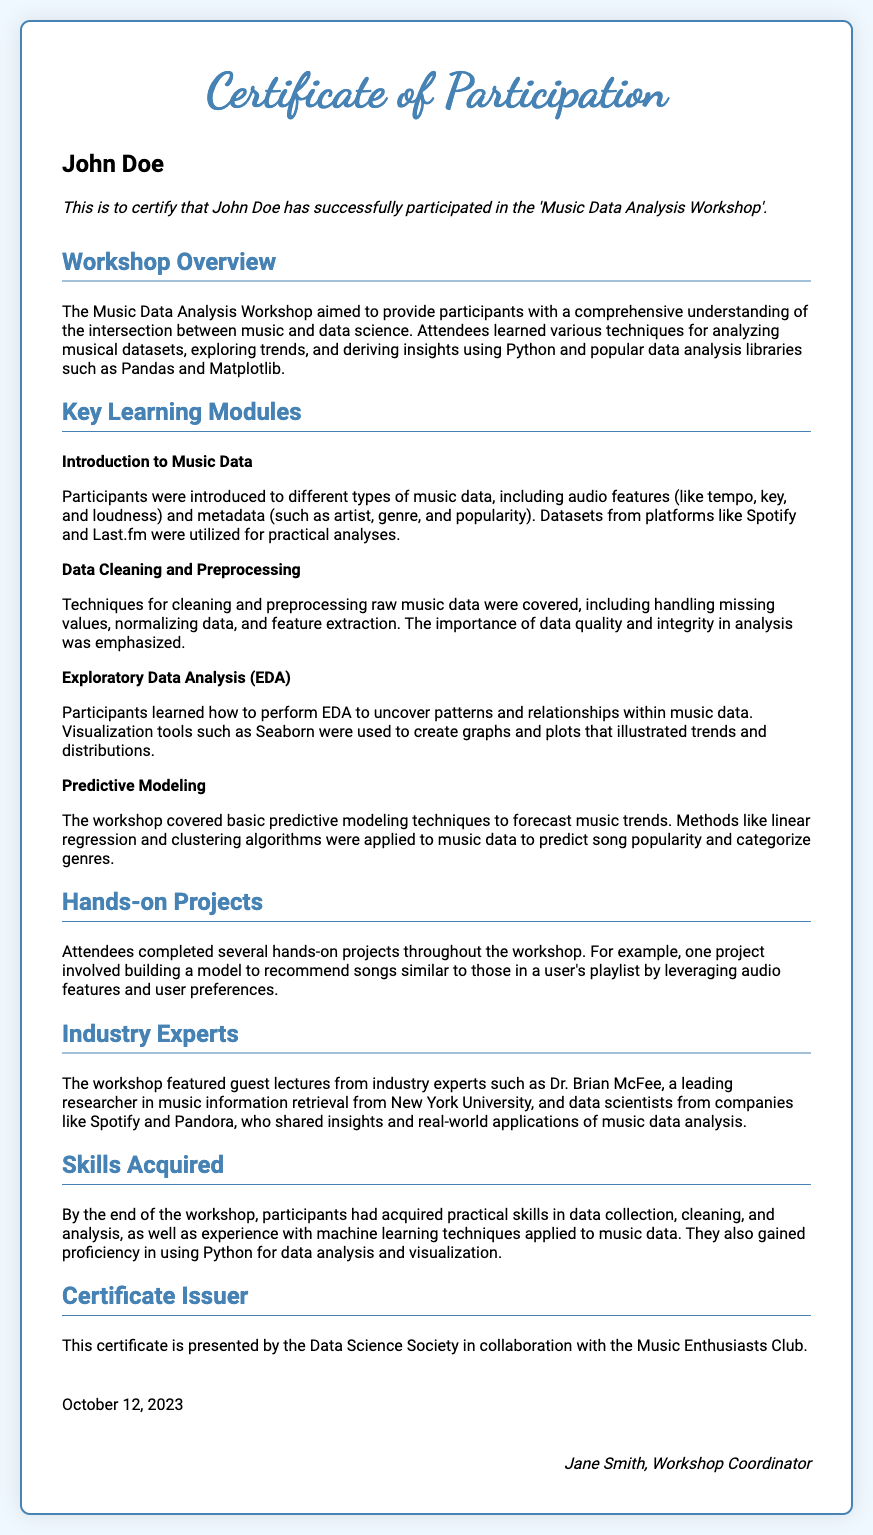What is the name of the recipient? The recipient's name is stated prominently on the certificate in a dedicated section.
Answer: John Doe What is the date of the certificate? The date is clearly mentioned at the bottom of the certificate.
Answer: October 12, 2023 Who issued the certificate? The issuer's name is listed in the "Certificate Issuer" section of the document.
Answer: Data Science Society in collaboration with the Music Enthusiasts Club What was the title of the workshop? The workshop's title is mentioned in the description of the participation on the certificate.
Answer: Music Data Analysis Workshop What was one of the skills acquired? The section on skills acquired lists practical skills learned during the workshop.
Answer: Data collection How many hands-on projects did attendees complete? The document mentions that several hands-on projects were completed but does not specify a number.
Answer: Several Who was a guest lecturer mentioned in the workshop? The document provides a name of a guest lecturer in the "Industry Experts" section.
Answer: Dr. Brian McFee What is the purpose of the workshop? The overview of the workshop details its primary aim.
Answer: To provide participants with a comprehensive understanding of the intersection between music and data science What techniques were taught for cleaning music data? The specific techniques covered are listed in the relevant module of the content section.
Answer: Handling missing values, normalizing data, and feature extraction 